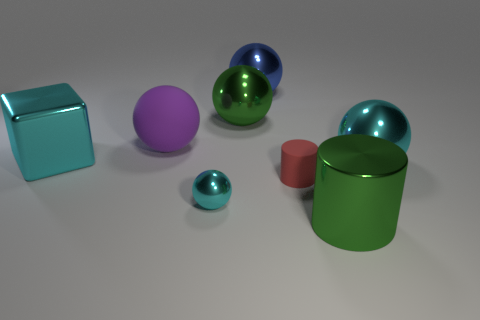Add 1 green spheres. How many objects exist? 9 Subtract all green spheres. How many spheres are left? 4 Subtract all rubber balls. How many balls are left? 4 Subtract 1 purple balls. How many objects are left? 7 Subtract all cylinders. How many objects are left? 6 Subtract 1 cylinders. How many cylinders are left? 1 Subtract all yellow spheres. Subtract all blue blocks. How many spheres are left? 5 Subtract all blue blocks. How many red cylinders are left? 1 Subtract all tiny yellow rubber spheres. Subtract all metallic blocks. How many objects are left? 7 Add 4 cyan shiny things. How many cyan shiny things are left? 7 